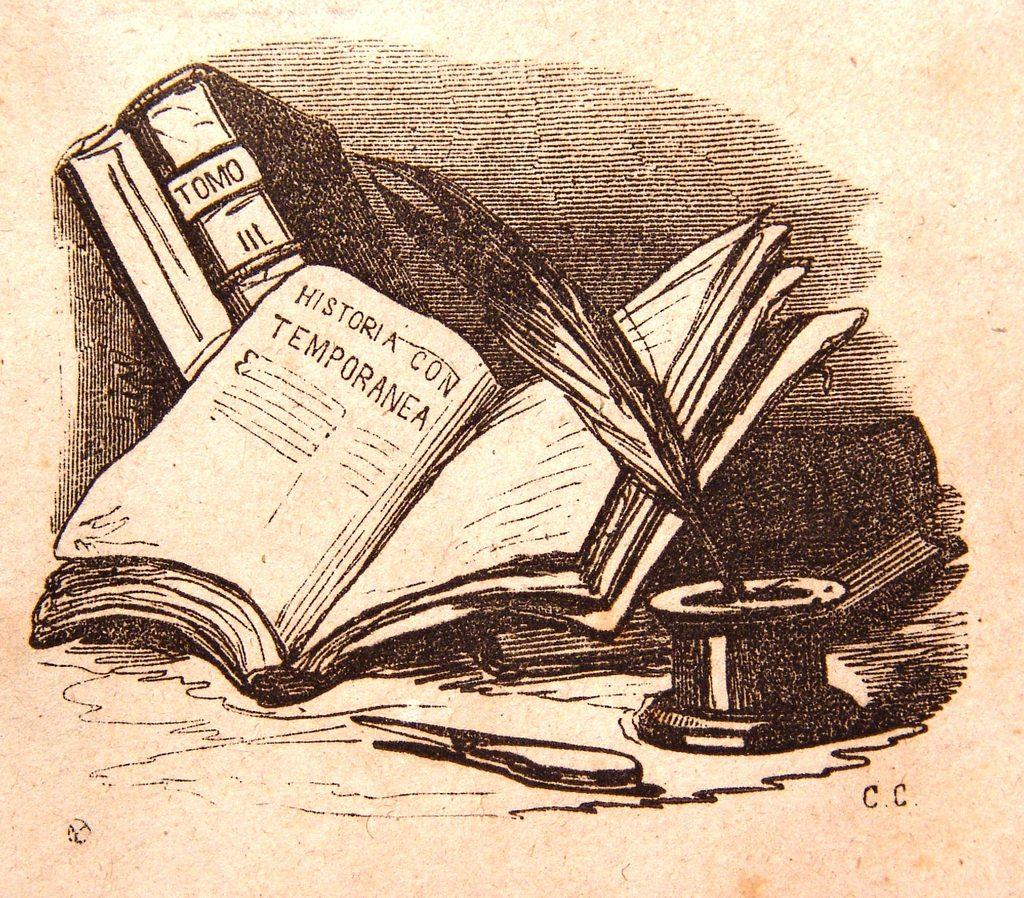Provide a one-sentence caption for the provided image. an open book that is pictured on a paper with HISTORIA CON TEMPORANEA inside of the book. 